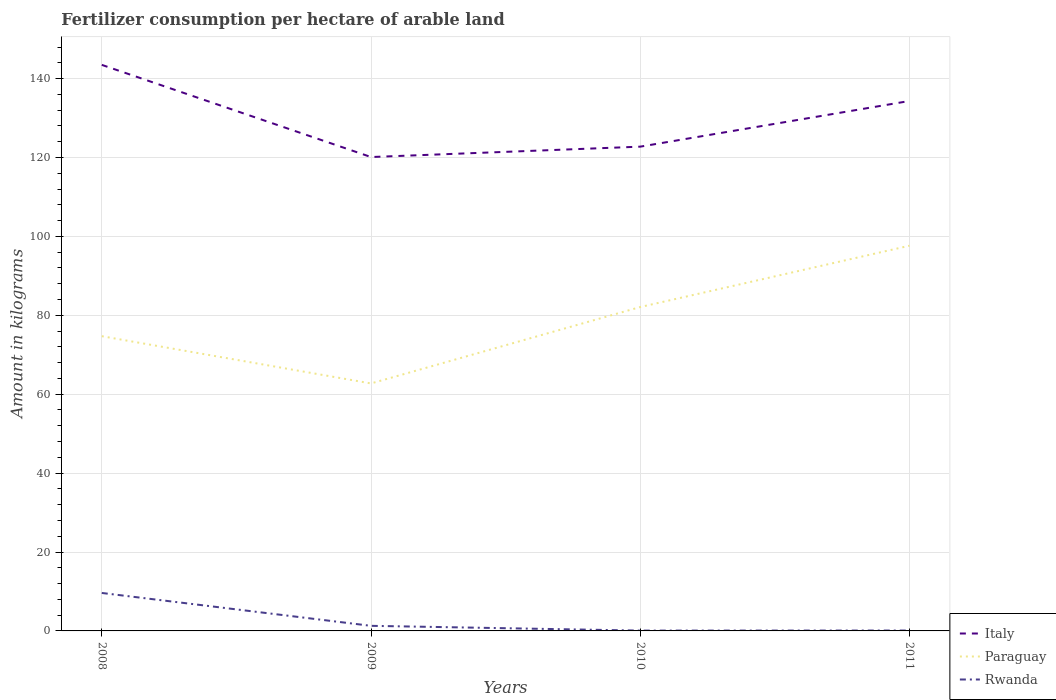Does the line corresponding to Rwanda intersect with the line corresponding to Paraguay?
Provide a short and direct response. No. Across all years, what is the maximum amount of fertilizer consumption in Paraguay?
Offer a very short reply. 62.73. What is the total amount of fertilizer consumption in Italy in the graph?
Keep it short and to the point. -11.58. What is the difference between the highest and the second highest amount of fertilizer consumption in Paraguay?
Give a very brief answer. 34.91. How many years are there in the graph?
Offer a terse response. 4. Are the values on the major ticks of Y-axis written in scientific E-notation?
Make the answer very short. No. Does the graph contain any zero values?
Provide a succinct answer. No. How are the legend labels stacked?
Your answer should be very brief. Vertical. What is the title of the graph?
Offer a very short reply. Fertilizer consumption per hectare of arable land. What is the label or title of the Y-axis?
Offer a terse response. Amount in kilograms. What is the Amount in kilograms in Italy in 2008?
Your answer should be very brief. 143.48. What is the Amount in kilograms in Paraguay in 2008?
Provide a succinct answer. 74.7. What is the Amount in kilograms in Rwanda in 2008?
Ensure brevity in your answer.  9.62. What is the Amount in kilograms in Italy in 2009?
Your response must be concise. 120.11. What is the Amount in kilograms of Paraguay in 2009?
Ensure brevity in your answer.  62.73. What is the Amount in kilograms in Rwanda in 2009?
Keep it short and to the point. 1.29. What is the Amount in kilograms in Italy in 2010?
Ensure brevity in your answer.  122.75. What is the Amount in kilograms in Paraguay in 2010?
Provide a short and direct response. 82.1. What is the Amount in kilograms in Rwanda in 2010?
Give a very brief answer. 0.08. What is the Amount in kilograms in Italy in 2011?
Your response must be concise. 134.32. What is the Amount in kilograms in Paraguay in 2011?
Offer a terse response. 97.64. What is the Amount in kilograms of Rwanda in 2011?
Keep it short and to the point. 0.1. Across all years, what is the maximum Amount in kilograms in Italy?
Keep it short and to the point. 143.48. Across all years, what is the maximum Amount in kilograms in Paraguay?
Offer a terse response. 97.64. Across all years, what is the maximum Amount in kilograms in Rwanda?
Your answer should be compact. 9.62. Across all years, what is the minimum Amount in kilograms in Italy?
Your response must be concise. 120.11. Across all years, what is the minimum Amount in kilograms in Paraguay?
Make the answer very short. 62.73. Across all years, what is the minimum Amount in kilograms in Rwanda?
Offer a very short reply. 0.08. What is the total Amount in kilograms in Italy in the graph?
Ensure brevity in your answer.  520.66. What is the total Amount in kilograms of Paraguay in the graph?
Your answer should be compact. 317.17. What is the total Amount in kilograms of Rwanda in the graph?
Offer a terse response. 11.1. What is the difference between the Amount in kilograms in Italy in 2008 and that in 2009?
Offer a very short reply. 23.36. What is the difference between the Amount in kilograms in Paraguay in 2008 and that in 2009?
Your answer should be compact. 11.98. What is the difference between the Amount in kilograms of Rwanda in 2008 and that in 2009?
Provide a succinct answer. 8.33. What is the difference between the Amount in kilograms in Italy in 2008 and that in 2010?
Offer a terse response. 20.73. What is the difference between the Amount in kilograms of Paraguay in 2008 and that in 2010?
Make the answer very short. -7.39. What is the difference between the Amount in kilograms of Rwanda in 2008 and that in 2010?
Offer a very short reply. 9.54. What is the difference between the Amount in kilograms of Italy in 2008 and that in 2011?
Provide a succinct answer. 9.15. What is the difference between the Amount in kilograms in Paraguay in 2008 and that in 2011?
Provide a short and direct response. -22.93. What is the difference between the Amount in kilograms in Rwanda in 2008 and that in 2011?
Provide a short and direct response. 9.52. What is the difference between the Amount in kilograms of Italy in 2009 and that in 2010?
Keep it short and to the point. -2.63. What is the difference between the Amount in kilograms of Paraguay in 2009 and that in 2010?
Your response must be concise. -19.37. What is the difference between the Amount in kilograms in Rwanda in 2009 and that in 2010?
Your answer should be compact. 1.21. What is the difference between the Amount in kilograms of Italy in 2009 and that in 2011?
Your answer should be compact. -14.21. What is the difference between the Amount in kilograms in Paraguay in 2009 and that in 2011?
Give a very brief answer. -34.91. What is the difference between the Amount in kilograms of Rwanda in 2009 and that in 2011?
Make the answer very short. 1.19. What is the difference between the Amount in kilograms of Italy in 2010 and that in 2011?
Your answer should be compact. -11.58. What is the difference between the Amount in kilograms of Paraguay in 2010 and that in 2011?
Offer a terse response. -15.54. What is the difference between the Amount in kilograms in Rwanda in 2010 and that in 2011?
Provide a succinct answer. -0.02. What is the difference between the Amount in kilograms in Italy in 2008 and the Amount in kilograms in Paraguay in 2009?
Provide a succinct answer. 80.75. What is the difference between the Amount in kilograms in Italy in 2008 and the Amount in kilograms in Rwanda in 2009?
Make the answer very short. 142.19. What is the difference between the Amount in kilograms in Paraguay in 2008 and the Amount in kilograms in Rwanda in 2009?
Your answer should be compact. 73.41. What is the difference between the Amount in kilograms in Italy in 2008 and the Amount in kilograms in Paraguay in 2010?
Ensure brevity in your answer.  61.38. What is the difference between the Amount in kilograms of Italy in 2008 and the Amount in kilograms of Rwanda in 2010?
Your answer should be compact. 143.39. What is the difference between the Amount in kilograms in Paraguay in 2008 and the Amount in kilograms in Rwanda in 2010?
Keep it short and to the point. 74.62. What is the difference between the Amount in kilograms of Italy in 2008 and the Amount in kilograms of Paraguay in 2011?
Provide a succinct answer. 45.84. What is the difference between the Amount in kilograms of Italy in 2008 and the Amount in kilograms of Rwanda in 2011?
Give a very brief answer. 143.38. What is the difference between the Amount in kilograms of Paraguay in 2008 and the Amount in kilograms of Rwanda in 2011?
Make the answer very short. 74.6. What is the difference between the Amount in kilograms in Italy in 2009 and the Amount in kilograms in Paraguay in 2010?
Your response must be concise. 38.02. What is the difference between the Amount in kilograms of Italy in 2009 and the Amount in kilograms of Rwanda in 2010?
Make the answer very short. 120.03. What is the difference between the Amount in kilograms of Paraguay in 2009 and the Amount in kilograms of Rwanda in 2010?
Your answer should be very brief. 62.65. What is the difference between the Amount in kilograms of Italy in 2009 and the Amount in kilograms of Paraguay in 2011?
Provide a succinct answer. 22.47. What is the difference between the Amount in kilograms in Italy in 2009 and the Amount in kilograms in Rwanda in 2011?
Offer a terse response. 120.01. What is the difference between the Amount in kilograms in Paraguay in 2009 and the Amount in kilograms in Rwanda in 2011?
Give a very brief answer. 62.63. What is the difference between the Amount in kilograms in Italy in 2010 and the Amount in kilograms in Paraguay in 2011?
Your response must be concise. 25.11. What is the difference between the Amount in kilograms in Italy in 2010 and the Amount in kilograms in Rwanda in 2011?
Provide a succinct answer. 122.65. What is the difference between the Amount in kilograms of Paraguay in 2010 and the Amount in kilograms of Rwanda in 2011?
Keep it short and to the point. 82. What is the average Amount in kilograms in Italy per year?
Provide a short and direct response. 130.16. What is the average Amount in kilograms of Paraguay per year?
Offer a very short reply. 79.29. What is the average Amount in kilograms of Rwanda per year?
Make the answer very short. 2.77. In the year 2008, what is the difference between the Amount in kilograms of Italy and Amount in kilograms of Paraguay?
Ensure brevity in your answer.  68.77. In the year 2008, what is the difference between the Amount in kilograms in Italy and Amount in kilograms in Rwanda?
Your response must be concise. 133.85. In the year 2008, what is the difference between the Amount in kilograms of Paraguay and Amount in kilograms of Rwanda?
Offer a terse response. 65.08. In the year 2009, what is the difference between the Amount in kilograms of Italy and Amount in kilograms of Paraguay?
Provide a short and direct response. 57.38. In the year 2009, what is the difference between the Amount in kilograms of Italy and Amount in kilograms of Rwanda?
Keep it short and to the point. 118.82. In the year 2009, what is the difference between the Amount in kilograms in Paraguay and Amount in kilograms in Rwanda?
Give a very brief answer. 61.44. In the year 2010, what is the difference between the Amount in kilograms in Italy and Amount in kilograms in Paraguay?
Provide a succinct answer. 40.65. In the year 2010, what is the difference between the Amount in kilograms of Italy and Amount in kilograms of Rwanda?
Your answer should be very brief. 122.66. In the year 2010, what is the difference between the Amount in kilograms of Paraguay and Amount in kilograms of Rwanda?
Keep it short and to the point. 82.01. In the year 2011, what is the difference between the Amount in kilograms of Italy and Amount in kilograms of Paraguay?
Make the answer very short. 36.68. In the year 2011, what is the difference between the Amount in kilograms in Italy and Amount in kilograms in Rwanda?
Offer a terse response. 134.22. In the year 2011, what is the difference between the Amount in kilograms in Paraguay and Amount in kilograms in Rwanda?
Make the answer very short. 97.54. What is the ratio of the Amount in kilograms in Italy in 2008 to that in 2009?
Keep it short and to the point. 1.19. What is the ratio of the Amount in kilograms of Paraguay in 2008 to that in 2009?
Provide a short and direct response. 1.19. What is the ratio of the Amount in kilograms in Rwanda in 2008 to that in 2009?
Give a very brief answer. 7.46. What is the ratio of the Amount in kilograms of Italy in 2008 to that in 2010?
Your response must be concise. 1.17. What is the ratio of the Amount in kilograms of Paraguay in 2008 to that in 2010?
Provide a succinct answer. 0.91. What is the ratio of the Amount in kilograms of Rwanda in 2008 to that in 2010?
Offer a very short reply. 115.06. What is the ratio of the Amount in kilograms of Italy in 2008 to that in 2011?
Provide a succinct answer. 1.07. What is the ratio of the Amount in kilograms of Paraguay in 2008 to that in 2011?
Offer a very short reply. 0.77. What is the ratio of the Amount in kilograms of Rwanda in 2008 to that in 2011?
Keep it short and to the point. 96.35. What is the ratio of the Amount in kilograms in Italy in 2009 to that in 2010?
Offer a very short reply. 0.98. What is the ratio of the Amount in kilograms in Paraguay in 2009 to that in 2010?
Give a very brief answer. 0.76. What is the ratio of the Amount in kilograms of Rwanda in 2009 to that in 2010?
Offer a very short reply. 15.43. What is the ratio of the Amount in kilograms in Italy in 2009 to that in 2011?
Offer a very short reply. 0.89. What is the ratio of the Amount in kilograms in Paraguay in 2009 to that in 2011?
Provide a short and direct response. 0.64. What is the ratio of the Amount in kilograms in Rwanda in 2009 to that in 2011?
Your answer should be compact. 12.92. What is the ratio of the Amount in kilograms of Italy in 2010 to that in 2011?
Provide a short and direct response. 0.91. What is the ratio of the Amount in kilograms of Paraguay in 2010 to that in 2011?
Your answer should be very brief. 0.84. What is the ratio of the Amount in kilograms of Rwanda in 2010 to that in 2011?
Your answer should be very brief. 0.84. What is the difference between the highest and the second highest Amount in kilograms in Italy?
Offer a very short reply. 9.15. What is the difference between the highest and the second highest Amount in kilograms of Paraguay?
Provide a short and direct response. 15.54. What is the difference between the highest and the second highest Amount in kilograms of Rwanda?
Make the answer very short. 8.33. What is the difference between the highest and the lowest Amount in kilograms in Italy?
Give a very brief answer. 23.36. What is the difference between the highest and the lowest Amount in kilograms of Paraguay?
Give a very brief answer. 34.91. What is the difference between the highest and the lowest Amount in kilograms of Rwanda?
Offer a terse response. 9.54. 